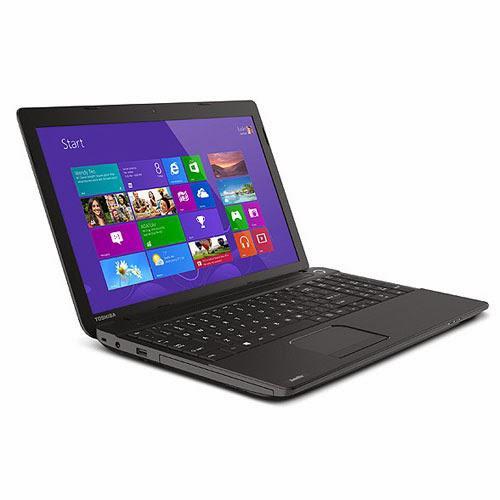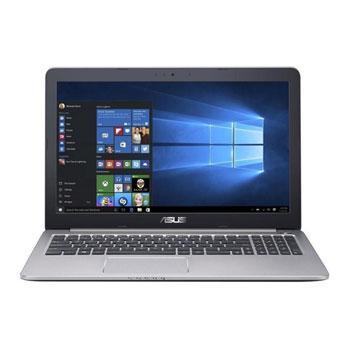The first image is the image on the left, the second image is the image on the right. For the images displayed, is the sentence "The computer in the image on the left has a black casing." factually correct? Answer yes or no. Yes. The first image is the image on the left, the second image is the image on the right. Considering the images on both sides, is "All laptops have the screen part attached to the keyboard base, and no laptop is displayed head-on." valid? Answer yes or no. No. 